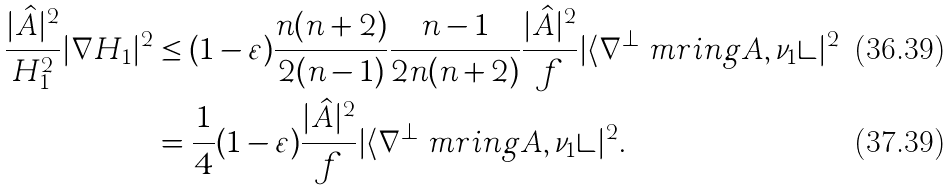<formula> <loc_0><loc_0><loc_500><loc_500>\frac { | \hat { A } | ^ { 2 } } { H _ { 1 } ^ { 2 } } | \nabla H _ { 1 } | ^ { 2 } & \leq ( 1 - \varepsilon ) \frac { n ( n + 2 ) } { 2 ( n - 1 ) } \frac { n - 1 } { 2 n ( n + 2 ) } \frac { | \hat { A } | ^ { 2 } } { f } | \langle \nabla ^ { \perp } \ m r i n g A , \nu _ { 1 } \rangle | ^ { 2 } \\ & = \frac { 1 } { 4 } ( 1 - \varepsilon ) \frac { | \hat { A } | ^ { 2 } } { f } | \langle \nabla ^ { \perp } \ m r i n g A , \nu _ { 1 } \rangle | ^ { 2 } .</formula> 